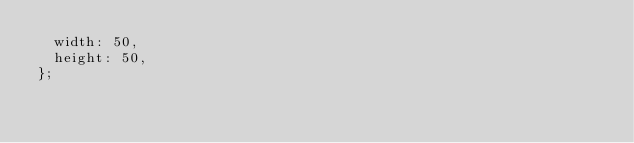<code> <loc_0><loc_0><loc_500><loc_500><_TypeScript_>  width: 50,
  height: 50,
};
</code> 